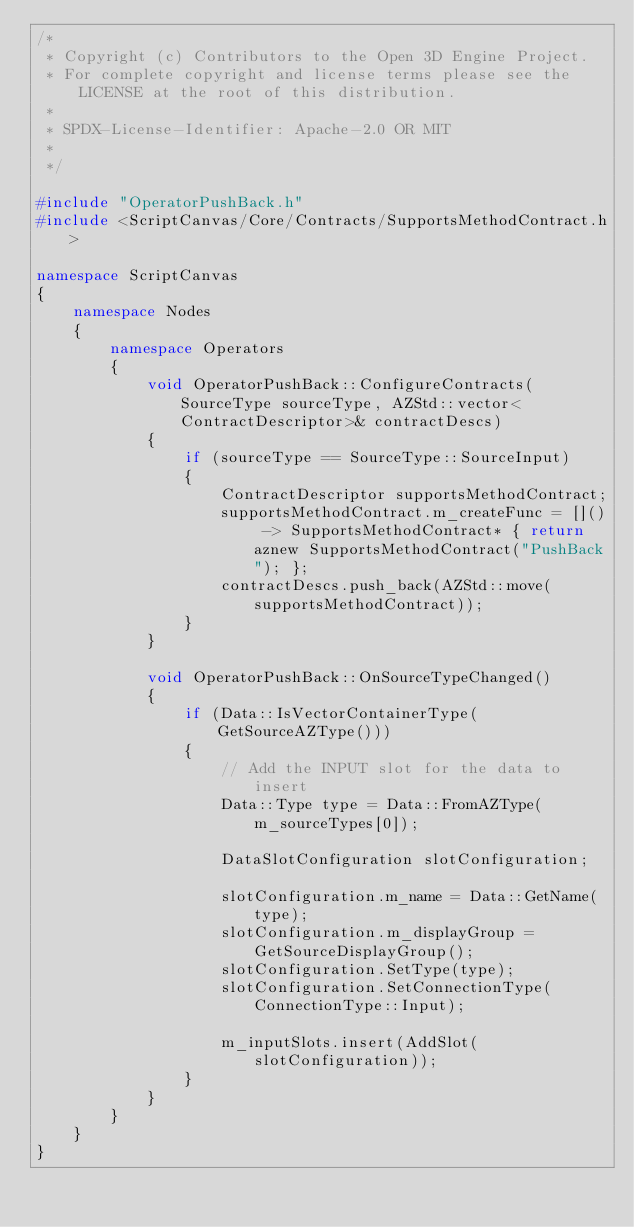Convert code to text. <code><loc_0><loc_0><loc_500><loc_500><_C++_>/*
 * Copyright (c) Contributors to the Open 3D Engine Project.
 * For complete copyright and license terms please see the LICENSE at the root of this distribution.
 *
 * SPDX-License-Identifier: Apache-2.0 OR MIT
 *
 */

#include "OperatorPushBack.h"
#include <ScriptCanvas/Core/Contracts/SupportsMethodContract.h>

namespace ScriptCanvas
{
    namespace Nodes
    {
        namespace Operators
        {
            void OperatorPushBack::ConfigureContracts(SourceType sourceType, AZStd::vector<ContractDescriptor>& contractDescs)
            {
                if (sourceType == SourceType::SourceInput)
                {
                    ContractDescriptor supportsMethodContract;
                    supportsMethodContract.m_createFunc = []() -> SupportsMethodContract* { return aznew SupportsMethodContract("PushBack"); };
                    contractDescs.push_back(AZStd::move(supportsMethodContract));
                }
            }

            void OperatorPushBack::OnSourceTypeChanged()
            {
                if (Data::IsVectorContainerType(GetSourceAZType()))
                {
                    // Add the INPUT slot for the data to insert
                    Data::Type type = Data::FromAZType(m_sourceTypes[0]);

                    DataSlotConfiguration slotConfiguration;

                    slotConfiguration.m_name = Data::GetName(type);
                    slotConfiguration.m_displayGroup = GetSourceDisplayGroup();
                    slotConfiguration.SetType(type);
                    slotConfiguration.SetConnectionType(ConnectionType::Input);

                    m_inputSlots.insert(AddSlot(slotConfiguration));
                }
            }
        }
    }
}
</code> 